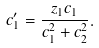Convert formula to latex. <formula><loc_0><loc_0><loc_500><loc_500>c _ { 1 } ^ { \prime } = \frac { z _ { 1 } c _ { 1 } } { c _ { 1 } ^ { 2 } + c _ { 2 } ^ { 2 } } .</formula> 